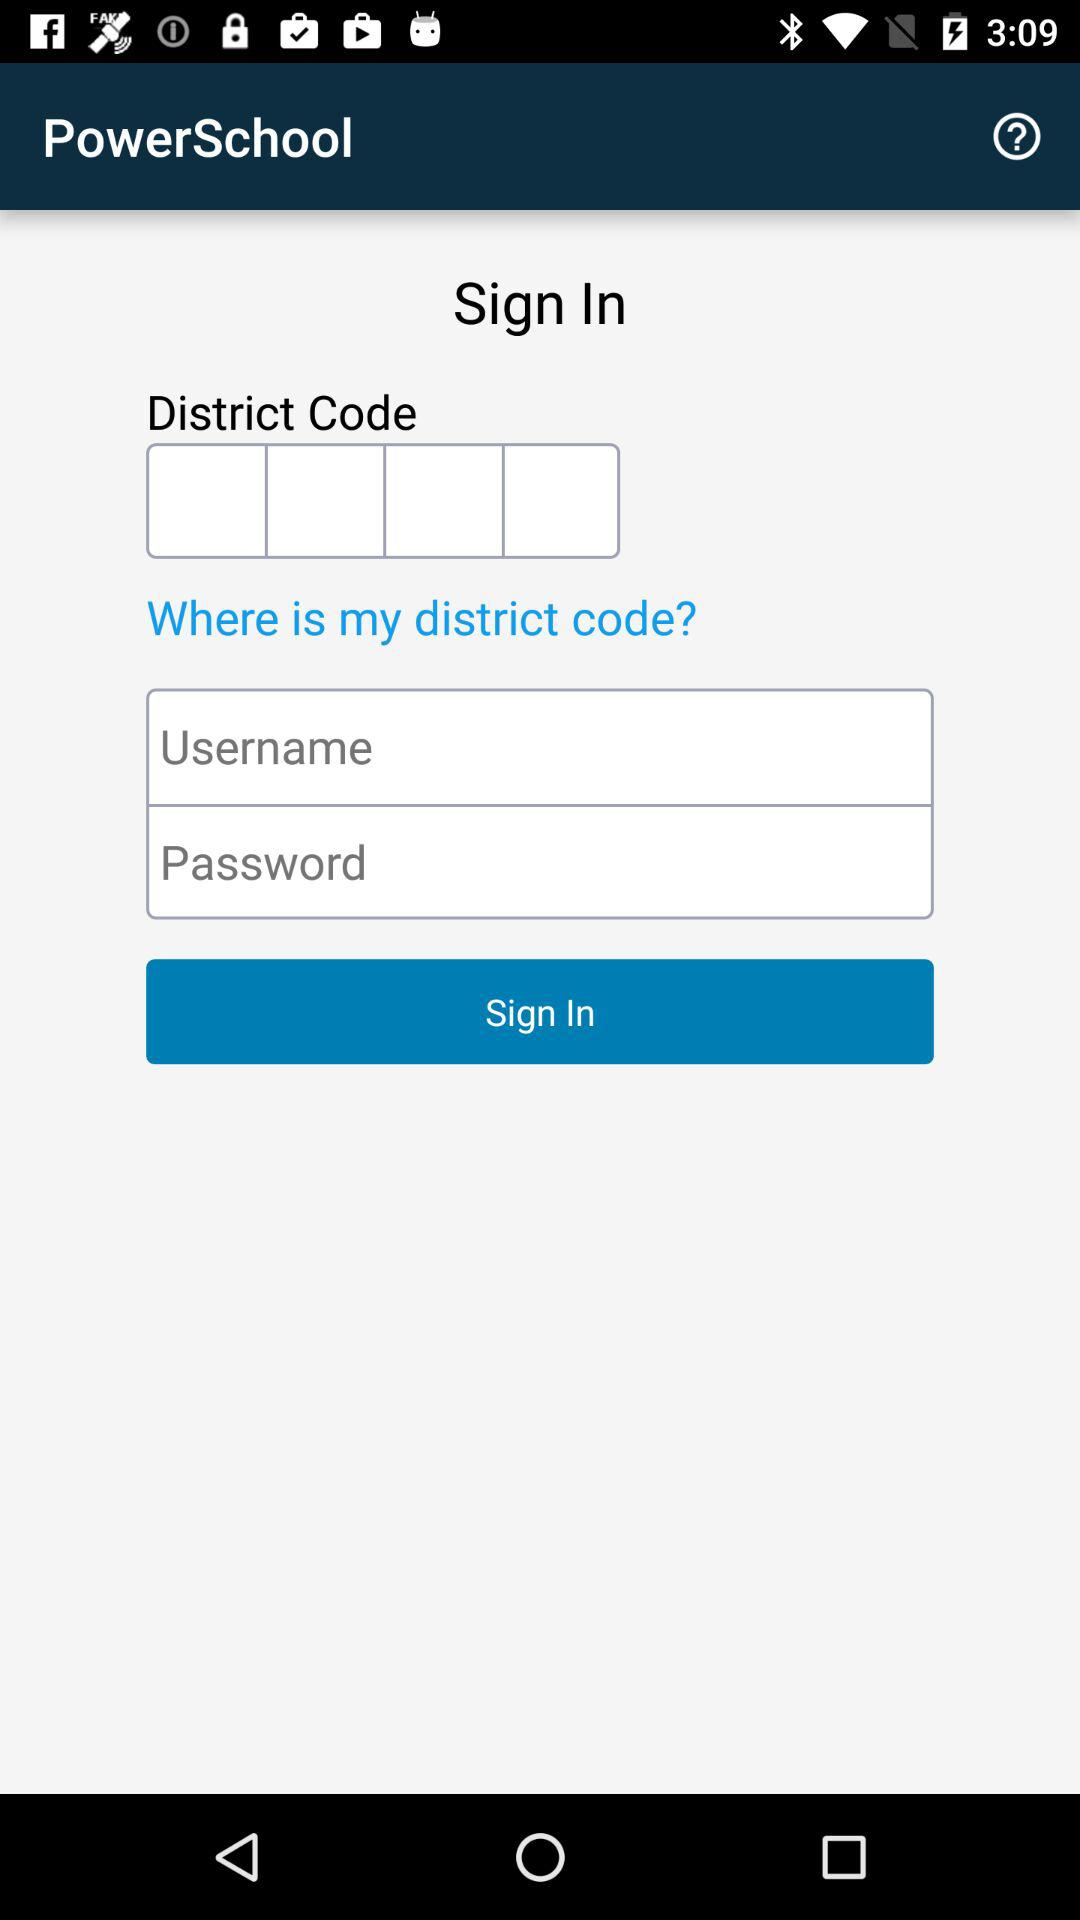How can we sign in? You can sign in with a district code, username and password. 